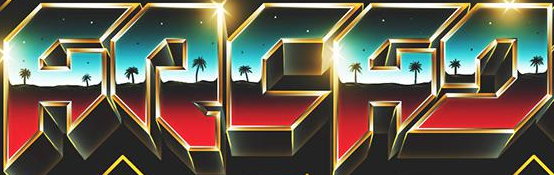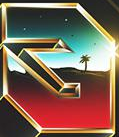What words can you see in these images in sequence, separated by a semicolon? ARCAD; # 